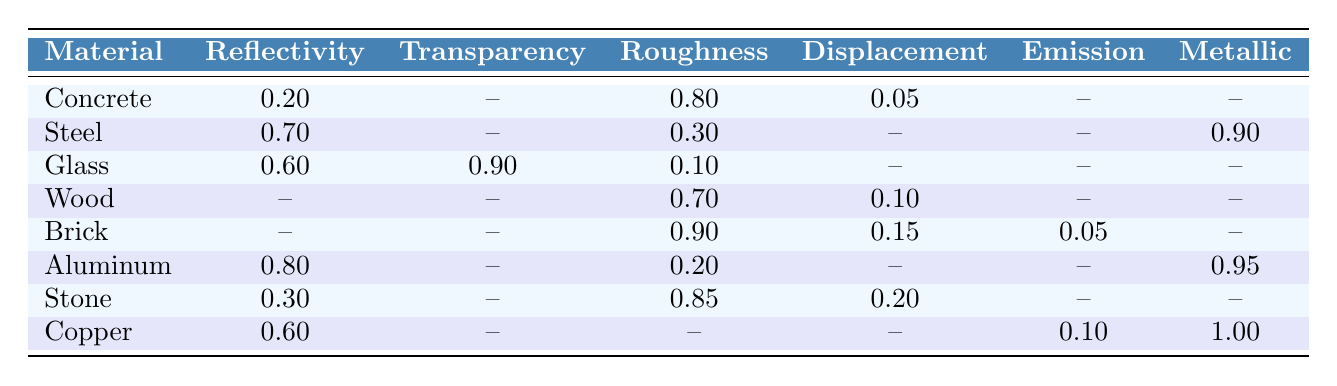What is the reflectivity of Glass? Referring to the table, the reflectivity value for Glass is clearly stated under the Reflectivity column. The value is 0.60.
Answer: 0.60 Which material has the highest metallic value? Looking at the Metallic column, Copper has the highest value at 1.00.
Answer: Copper What is the roughness of Steel? The table shows that Steel has a roughness value of 0.30 listed in the Roughness column.
Answer: 0.30 Does Brick have a displacement value? Checking the table, Brick has a displacement value of 0.15. Therefore, the answer is yes.
Answer: Yes Which materials have a roughness value greater than 0.80? Analyzing the Roughness column, Concrete (0.80), Brick (0.90), Wood (0.70), Stone (0.85), and Steel (0.30) were reviewed, finding Concrete, Brick, and Stone have a roughness value greater than 0.80, while Wood and Steel do not.
Answer: Concrete, Brick, Stone What is the emission value of Copper? The table indicates that Copper has an emission value of 0.10 under the Emission column.
Answer: 0.10 What is the average roughness of all materials? Adding the roughness values: 0.80 (Concrete), 0.30 (Steel), 0.10 (Glass), 0.70 (Wood), 0.90 (Brick), 0.20 (Aluminum), 0.85 (Stone) gives a total of 3.15 for the roughness. There are 7 materials, so dividing by 7 results in an average of approximately 0.45.
Answer: 0.45 Does any material have both high reflectivity and metallic value? Reviewing the Reflectivity and Metallic columns, Steel has a high reflectivity (0.70) and a high metallic value (0.90), thus meeting the condition.
Answer: Yes Which material has both a displacement value and high roughness? Exploring the table for materials with both roughness greater than 0.70 and non-zero displacement values, Brick (0.90 roughness, 0.15 displacement) and Stone (0.85 roughness, 0.20 displacement) qualify.
Answer: Brick, Stone What is the total reflectivity value of all materials listed? Adding the reflectivity values: 0.20 (Concrete) + 0.70 (Steel) + 0.60 (Glass) + 0.80 (Aluminum) + 0.30 (Stone) + 0.60 (Copper) totals 3.20. However, three materials have no reflectivity values (Wood, Brick), so the total is based on provided reflectivity values only.
Answer: 3.20 